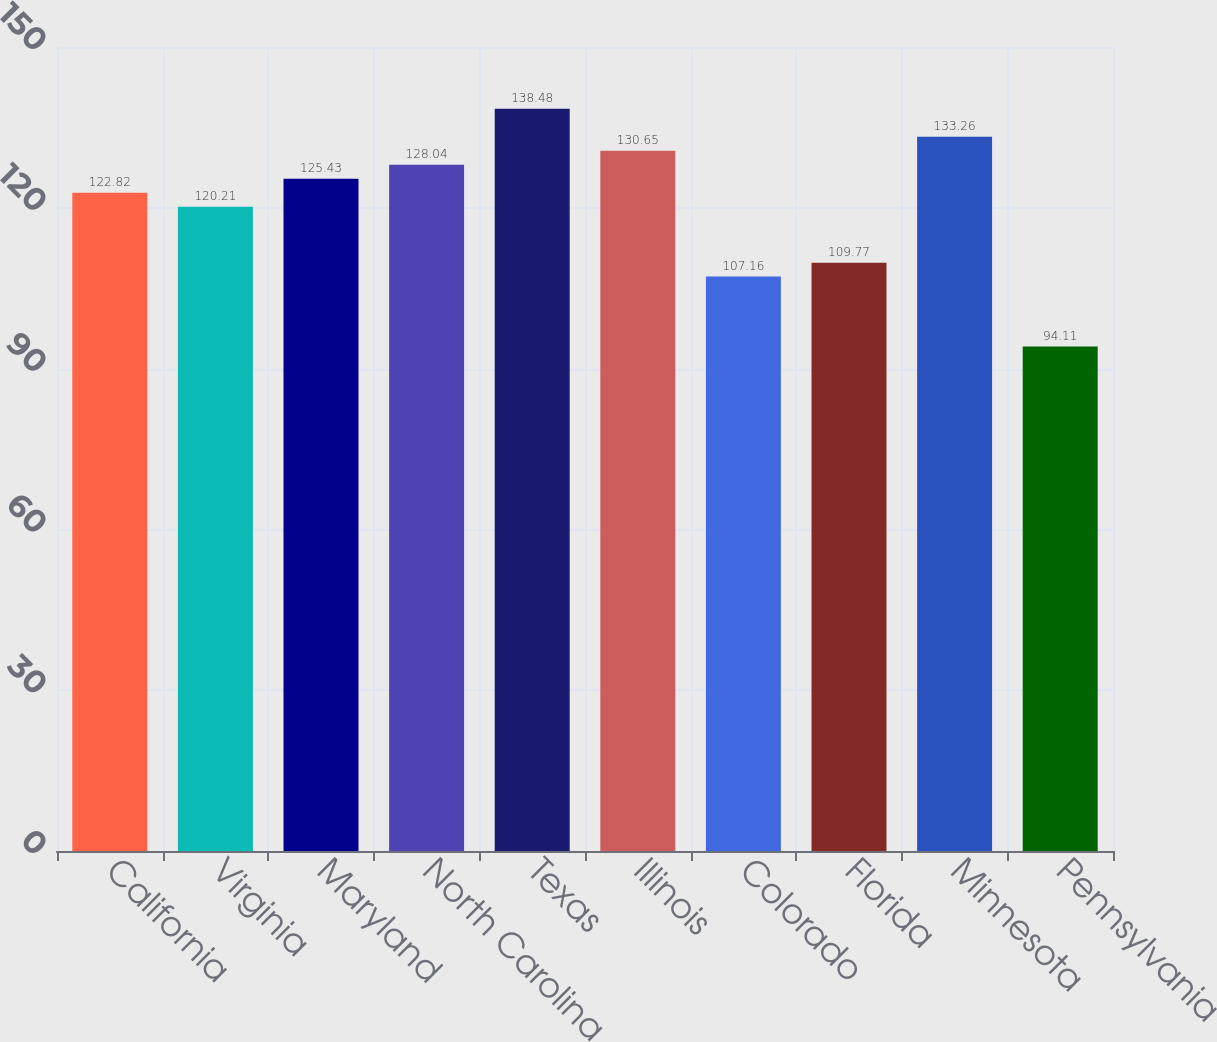<chart> <loc_0><loc_0><loc_500><loc_500><bar_chart><fcel>California<fcel>Virginia<fcel>Maryland<fcel>North Carolina<fcel>Texas<fcel>Illinois<fcel>Colorado<fcel>Florida<fcel>Minnesota<fcel>Pennsylvania<nl><fcel>122.82<fcel>120.21<fcel>125.43<fcel>128.04<fcel>138.48<fcel>130.65<fcel>107.16<fcel>109.77<fcel>133.26<fcel>94.11<nl></chart> 